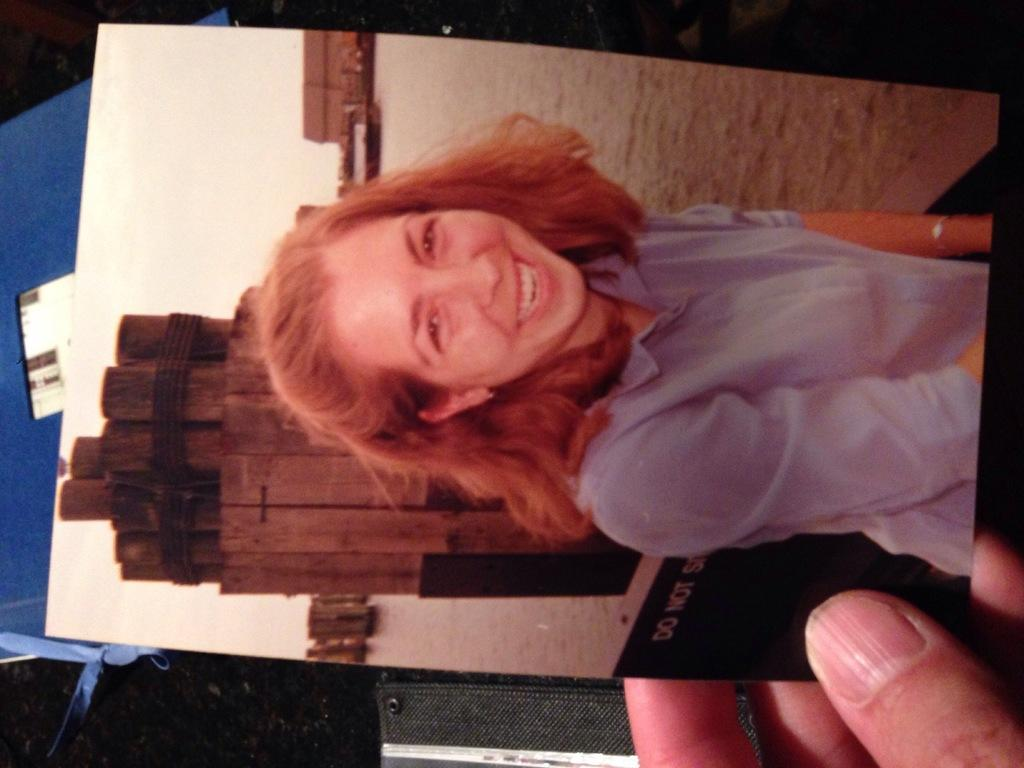Who is present in the image? There is a person in the image. What is the person holding? The person is holding a photo. Who is depicted in the photo? The photo is of a woman. What can be seen in the background of the image? There are objects in the background of the image. How many books are visible in the image? There are no books visible in the image. Is there a brake pedal present in the image? There is no brake pedal present in the image. 